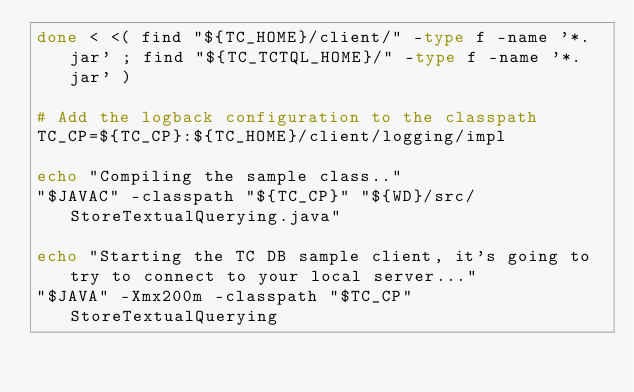<code> <loc_0><loc_0><loc_500><loc_500><_Bash_>done < <( find "${TC_HOME}/client/" -type f -name '*.jar' ; find "${TC_TCTQL_HOME}/" -type f -name '*.jar' )

# Add the logback configuration to the classpath
TC_CP=${TC_CP}:${TC_HOME}/client/logging/impl

echo "Compiling the sample class.."
"$JAVAC" -classpath "${TC_CP}" "${WD}/src/StoreTextualQuerying.java"

echo "Starting the TC DB sample client, it's going to try to connect to your local server..."
"$JAVA" -Xmx200m -classpath "$TC_CP" StoreTextualQuerying
</code> 